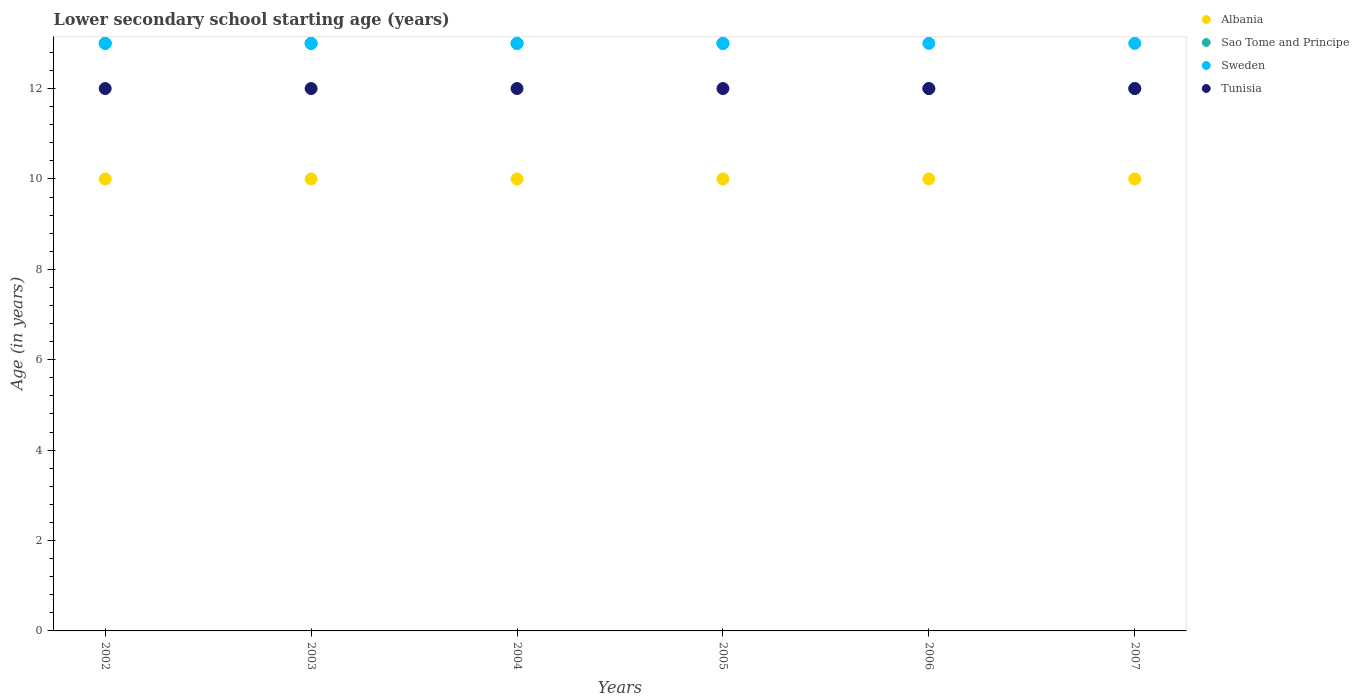What is the lower secondary school starting age of children in Tunisia in 2006?
Offer a very short reply. 12. Across all years, what is the maximum lower secondary school starting age of children in Sao Tome and Principe?
Give a very brief answer. 13. Across all years, what is the minimum lower secondary school starting age of children in Albania?
Offer a terse response. 10. In which year was the lower secondary school starting age of children in Albania minimum?
Ensure brevity in your answer.  2002. What is the total lower secondary school starting age of children in Albania in the graph?
Provide a succinct answer. 60. What is the difference between the lower secondary school starting age of children in Tunisia in 2003 and the lower secondary school starting age of children in Albania in 2007?
Offer a very short reply. 2. Is the difference between the lower secondary school starting age of children in Albania in 2003 and 2005 greater than the difference between the lower secondary school starting age of children in Sweden in 2003 and 2005?
Offer a very short reply. No. In how many years, is the lower secondary school starting age of children in Tunisia greater than the average lower secondary school starting age of children in Tunisia taken over all years?
Offer a very short reply. 0. Is it the case that in every year, the sum of the lower secondary school starting age of children in Albania and lower secondary school starting age of children in Tunisia  is greater than the lower secondary school starting age of children in Sao Tome and Principe?
Offer a very short reply. Yes. Does the lower secondary school starting age of children in Sao Tome and Principe monotonically increase over the years?
Offer a terse response. No. How many years are there in the graph?
Your answer should be compact. 6. What is the difference between two consecutive major ticks on the Y-axis?
Give a very brief answer. 2. Are the values on the major ticks of Y-axis written in scientific E-notation?
Your answer should be compact. No. Does the graph contain any zero values?
Keep it short and to the point. No. Does the graph contain grids?
Your answer should be very brief. No. How many legend labels are there?
Provide a short and direct response. 4. How are the legend labels stacked?
Give a very brief answer. Vertical. What is the title of the graph?
Your answer should be compact. Lower secondary school starting age (years). What is the label or title of the X-axis?
Keep it short and to the point. Years. What is the label or title of the Y-axis?
Your answer should be very brief. Age (in years). What is the Age (in years) of Albania in 2002?
Provide a succinct answer. 10. What is the Age (in years) in Albania in 2003?
Provide a short and direct response. 10. What is the Age (in years) of Sao Tome and Principe in 2003?
Your response must be concise. 13. What is the Age (in years) of Sao Tome and Principe in 2004?
Provide a short and direct response. 13. What is the Age (in years) in Tunisia in 2004?
Offer a terse response. 12. What is the Age (in years) of Albania in 2005?
Offer a terse response. 10. What is the Age (in years) of Tunisia in 2005?
Provide a short and direct response. 12. What is the Age (in years) in Albania in 2006?
Keep it short and to the point. 10. What is the Age (in years) of Sao Tome and Principe in 2006?
Your response must be concise. 12. What is the Age (in years) in Sweden in 2006?
Provide a short and direct response. 13. What is the Age (in years) of Sweden in 2007?
Make the answer very short. 13. What is the Age (in years) in Tunisia in 2007?
Offer a terse response. 12. Across all years, what is the maximum Age (in years) in Sao Tome and Principe?
Your answer should be very brief. 13. Across all years, what is the maximum Age (in years) of Sweden?
Provide a short and direct response. 13. Across all years, what is the maximum Age (in years) in Tunisia?
Keep it short and to the point. 12. Across all years, what is the minimum Age (in years) in Sao Tome and Principe?
Give a very brief answer. 12. Across all years, what is the minimum Age (in years) of Tunisia?
Ensure brevity in your answer.  12. What is the total Age (in years) in Albania in the graph?
Give a very brief answer. 60. What is the total Age (in years) of Sao Tome and Principe in the graph?
Your answer should be compact. 76. What is the total Age (in years) of Tunisia in the graph?
Give a very brief answer. 72. What is the difference between the Age (in years) of Albania in 2002 and that in 2003?
Provide a succinct answer. 0. What is the difference between the Age (in years) in Sao Tome and Principe in 2002 and that in 2003?
Provide a succinct answer. 0. What is the difference between the Age (in years) of Sweden in 2002 and that in 2003?
Offer a very short reply. 0. What is the difference between the Age (in years) in Tunisia in 2002 and that in 2003?
Give a very brief answer. 0. What is the difference between the Age (in years) of Albania in 2002 and that in 2004?
Keep it short and to the point. 0. What is the difference between the Age (in years) in Sao Tome and Principe in 2002 and that in 2004?
Provide a short and direct response. 0. What is the difference between the Age (in years) of Sweden in 2002 and that in 2004?
Make the answer very short. 0. What is the difference between the Age (in years) in Sao Tome and Principe in 2002 and that in 2005?
Keep it short and to the point. 0. What is the difference between the Age (in years) of Sweden in 2002 and that in 2005?
Keep it short and to the point. 0. What is the difference between the Age (in years) in Sao Tome and Principe in 2002 and that in 2006?
Make the answer very short. 1. What is the difference between the Age (in years) in Sweden in 2002 and that in 2006?
Ensure brevity in your answer.  0. What is the difference between the Age (in years) of Tunisia in 2002 and that in 2006?
Ensure brevity in your answer.  0. What is the difference between the Age (in years) of Albania in 2002 and that in 2007?
Offer a terse response. 0. What is the difference between the Age (in years) in Sao Tome and Principe in 2002 and that in 2007?
Your response must be concise. 1. What is the difference between the Age (in years) in Sweden in 2003 and that in 2004?
Keep it short and to the point. 0. What is the difference between the Age (in years) in Albania in 2003 and that in 2005?
Give a very brief answer. 0. What is the difference between the Age (in years) of Sao Tome and Principe in 2003 and that in 2005?
Make the answer very short. 0. What is the difference between the Age (in years) in Albania in 2003 and that in 2006?
Offer a terse response. 0. What is the difference between the Age (in years) of Sao Tome and Principe in 2003 and that in 2006?
Offer a very short reply. 1. What is the difference between the Age (in years) of Albania in 2003 and that in 2007?
Keep it short and to the point. 0. What is the difference between the Age (in years) of Sweden in 2003 and that in 2007?
Your response must be concise. 0. What is the difference between the Age (in years) in Tunisia in 2003 and that in 2007?
Keep it short and to the point. 0. What is the difference between the Age (in years) in Albania in 2004 and that in 2005?
Provide a succinct answer. 0. What is the difference between the Age (in years) of Albania in 2005 and that in 2006?
Your answer should be very brief. 0. What is the difference between the Age (in years) of Sweden in 2005 and that in 2006?
Give a very brief answer. 0. What is the difference between the Age (in years) in Tunisia in 2005 and that in 2006?
Offer a terse response. 0. What is the difference between the Age (in years) in Sao Tome and Principe in 2005 and that in 2007?
Give a very brief answer. 1. What is the difference between the Age (in years) of Sweden in 2005 and that in 2007?
Offer a terse response. 0. What is the difference between the Age (in years) in Sao Tome and Principe in 2006 and that in 2007?
Ensure brevity in your answer.  0. What is the difference between the Age (in years) in Sweden in 2006 and that in 2007?
Offer a very short reply. 0. What is the difference between the Age (in years) in Albania in 2002 and the Age (in years) in Sao Tome and Principe in 2003?
Ensure brevity in your answer.  -3. What is the difference between the Age (in years) of Albania in 2002 and the Age (in years) of Sweden in 2003?
Offer a very short reply. -3. What is the difference between the Age (in years) of Sao Tome and Principe in 2002 and the Age (in years) of Tunisia in 2003?
Your answer should be very brief. 1. What is the difference between the Age (in years) of Sweden in 2002 and the Age (in years) of Tunisia in 2003?
Give a very brief answer. 1. What is the difference between the Age (in years) of Albania in 2002 and the Age (in years) of Sweden in 2004?
Your response must be concise. -3. What is the difference between the Age (in years) in Sao Tome and Principe in 2002 and the Age (in years) in Sweden in 2004?
Offer a very short reply. 0. What is the difference between the Age (in years) in Albania in 2002 and the Age (in years) in Sao Tome and Principe in 2005?
Your answer should be very brief. -3. What is the difference between the Age (in years) in Albania in 2002 and the Age (in years) in Sweden in 2005?
Provide a succinct answer. -3. What is the difference between the Age (in years) in Albania in 2002 and the Age (in years) in Tunisia in 2005?
Ensure brevity in your answer.  -2. What is the difference between the Age (in years) in Sao Tome and Principe in 2002 and the Age (in years) in Sweden in 2005?
Your answer should be compact. 0. What is the difference between the Age (in years) of Sao Tome and Principe in 2002 and the Age (in years) of Tunisia in 2005?
Give a very brief answer. 1. What is the difference between the Age (in years) in Sweden in 2002 and the Age (in years) in Tunisia in 2005?
Provide a short and direct response. 1. What is the difference between the Age (in years) in Albania in 2002 and the Age (in years) in Sweden in 2006?
Your answer should be very brief. -3. What is the difference between the Age (in years) of Sao Tome and Principe in 2002 and the Age (in years) of Sweden in 2006?
Provide a succinct answer. 0. What is the difference between the Age (in years) in Sao Tome and Principe in 2002 and the Age (in years) in Tunisia in 2006?
Keep it short and to the point. 1. What is the difference between the Age (in years) in Sweden in 2002 and the Age (in years) in Tunisia in 2006?
Ensure brevity in your answer.  1. What is the difference between the Age (in years) in Albania in 2002 and the Age (in years) in Tunisia in 2007?
Provide a succinct answer. -2. What is the difference between the Age (in years) in Sao Tome and Principe in 2002 and the Age (in years) in Sweden in 2007?
Offer a very short reply. 0. What is the difference between the Age (in years) in Albania in 2003 and the Age (in years) in Sweden in 2004?
Give a very brief answer. -3. What is the difference between the Age (in years) in Sweden in 2003 and the Age (in years) in Tunisia in 2004?
Give a very brief answer. 1. What is the difference between the Age (in years) of Albania in 2003 and the Age (in years) of Sao Tome and Principe in 2005?
Provide a short and direct response. -3. What is the difference between the Age (in years) of Albania in 2003 and the Age (in years) of Sweden in 2005?
Your answer should be compact. -3. What is the difference between the Age (in years) of Albania in 2003 and the Age (in years) of Tunisia in 2005?
Your response must be concise. -2. What is the difference between the Age (in years) of Sao Tome and Principe in 2003 and the Age (in years) of Sweden in 2005?
Offer a very short reply. 0. What is the difference between the Age (in years) in Sao Tome and Principe in 2003 and the Age (in years) in Tunisia in 2005?
Your response must be concise. 1. What is the difference between the Age (in years) of Albania in 2003 and the Age (in years) of Sao Tome and Principe in 2006?
Make the answer very short. -2. What is the difference between the Age (in years) in Albania in 2003 and the Age (in years) in Sweden in 2006?
Give a very brief answer. -3. What is the difference between the Age (in years) in Sao Tome and Principe in 2003 and the Age (in years) in Sweden in 2006?
Offer a very short reply. 0. What is the difference between the Age (in years) of Albania in 2003 and the Age (in years) of Sao Tome and Principe in 2007?
Keep it short and to the point. -2. What is the difference between the Age (in years) in Albania in 2003 and the Age (in years) in Sweden in 2007?
Ensure brevity in your answer.  -3. What is the difference between the Age (in years) of Sao Tome and Principe in 2003 and the Age (in years) of Sweden in 2007?
Ensure brevity in your answer.  0. What is the difference between the Age (in years) in Albania in 2004 and the Age (in years) in Sweden in 2005?
Your response must be concise. -3. What is the difference between the Age (in years) of Albania in 2004 and the Age (in years) of Tunisia in 2005?
Provide a short and direct response. -2. What is the difference between the Age (in years) in Sao Tome and Principe in 2004 and the Age (in years) in Sweden in 2005?
Provide a short and direct response. 0. What is the difference between the Age (in years) of Sweden in 2004 and the Age (in years) of Tunisia in 2005?
Offer a terse response. 1. What is the difference between the Age (in years) in Albania in 2004 and the Age (in years) in Sao Tome and Principe in 2006?
Provide a succinct answer. -2. What is the difference between the Age (in years) in Albania in 2004 and the Age (in years) in Sweden in 2006?
Your answer should be very brief. -3. What is the difference between the Age (in years) of Sao Tome and Principe in 2004 and the Age (in years) of Sweden in 2006?
Provide a succinct answer. 0. What is the difference between the Age (in years) in Albania in 2004 and the Age (in years) in Sao Tome and Principe in 2007?
Offer a very short reply. -2. What is the difference between the Age (in years) of Sao Tome and Principe in 2004 and the Age (in years) of Sweden in 2007?
Offer a terse response. 0. What is the difference between the Age (in years) in Sao Tome and Principe in 2004 and the Age (in years) in Tunisia in 2007?
Provide a succinct answer. 1. What is the difference between the Age (in years) in Sweden in 2004 and the Age (in years) in Tunisia in 2007?
Offer a terse response. 1. What is the difference between the Age (in years) in Albania in 2005 and the Age (in years) in Sao Tome and Principe in 2006?
Your answer should be compact. -2. What is the difference between the Age (in years) of Albania in 2005 and the Age (in years) of Sweden in 2006?
Ensure brevity in your answer.  -3. What is the difference between the Age (in years) in Sao Tome and Principe in 2005 and the Age (in years) in Sweden in 2006?
Provide a short and direct response. 0. What is the difference between the Age (in years) in Sao Tome and Principe in 2005 and the Age (in years) in Tunisia in 2006?
Your answer should be compact. 1. What is the difference between the Age (in years) of Albania in 2005 and the Age (in years) of Sweden in 2007?
Give a very brief answer. -3. What is the difference between the Age (in years) in Albania in 2005 and the Age (in years) in Tunisia in 2007?
Ensure brevity in your answer.  -2. What is the difference between the Age (in years) in Sao Tome and Principe in 2005 and the Age (in years) in Tunisia in 2007?
Ensure brevity in your answer.  1. What is the difference between the Age (in years) in Sao Tome and Principe in 2006 and the Age (in years) in Sweden in 2007?
Ensure brevity in your answer.  -1. What is the difference between the Age (in years) in Sao Tome and Principe in 2006 and the Age (in years) in Tunisia in 2007?
Offer a very short reply. 0. What is the difference between the Age (in years) in Sweden in 2006 and the Age (in years) in Tunisia in 2007?
Provide a short and direct response. 1. What is the average Age (in years) of Albania per year?
Ensure brevity in your answer.  10. What is the average Age (in years) of Sao Tome and Principe per year?
Provide a short and direct response. 12.67. What is the average Age (in years) in Tunisia per year?
Ensure brevity in your answer.  12. In the year 2002, what is the difference between the Age (in years) of Albania and Age (in years) of Sweden?
Provide a succinct answer. -3. In the year 2002, what is the difference between the Age (in years) of Albania and Age (in years) of Tunisia?
Provide a succinct answer. -2. In the year 2002, what is the difference between the Age (in years) in Sao Tome and Principe and Age (in years) in Sweden?
Your answer should be compact. 0. In the year 2003, what is the difference between the Age (in years) of Albania and Age (in years) of Sao Tome and Principe?
Keep it short and to the point. -3. In the year 2003, what is the difference between the Age (in years) of Albania and Age (in years) of Sweden?
Give a very brief answer. -3. In the year 2003, what is the difference between the Age (in years) of Albania and Age (in years) of Tunisia?
Keep it short and to the point. -2. In the year 2003, what is the difference between the Age (in years) of Sao Tome and Principe and Age (in years) of Tunisia?
Offer a terse response. 1. In the year 2004, what is the difference between the Age (in years) in Albania and Age (in years) in Tunisia?
Your response must be concise. -2. In the year 2005, what is the difference between the Age (in years) of Albania and Age (in years) of Sao Tome and Principe?
Offer a very short reply. -3. In the year 2005, what is the difference between the Age (in years) in Albania and Age (in years) in Sweden?
Provide a short and direct response. -3. In the year 2005, what is the difference between the Age (in years) in Albania and Age (in years) in Tunisia?
Make the answer very short. -2. In the year 2006, what is the difference between the Age (in years) of Albania and Age (in years) of Sao Tome and Principe?
Your response must be concise. -2. In the year 2006, what is the difference between the Age (in years) in Albania and Age (in years) in Tunisia?
Your answer should be compact. -2. In the year 2006, what is the difference between the Age (in years) of Sao Tome and Principe and Age (in years) of Sweden?
Your answer should be very brief. -1. In the year 2006, what is the difference between the Age (in years) of Sweden and Age (in years) of Tunisia?
Make the answer very short. 1. In the year 2007, what is the difference between the Age (in years) of Albania and Age (in years) of Sao Tome and Principe?
Ensure brevity in your answer.  -2. In the year 2007, what is the difference between the Age (in years) of Albania and Age (in years) of Sweden?
Keep it short and to the point. -3. In the year 2007, what is the difference between the Age (in years) of Sao Tome and Principe and Age (in years) of Tunisia?
Your answer should be compact. 0. In the year 2007, what is the difference between the Age (in years) in Sweden and Age (in years) in Tunisia?
Your response must be concise. 1. What is the ratio of the Age (in years) in Sao Tome and Principe in 2002 to that in 2003?
Give a very brief answer. 1. What is the ratio of the Age (in years) in Sao Tome and Principe in 2002 to that in 2005?
Your answer should be compact. 1. What is the ratio of the Age (in years) in Sweden in 2002 to that in 2005?
Your answer should be compact. 1. What is the ratio of the Age (in years) in Sao Tome and Principe in 2002 to that in 2006?
Make the answer very short. 1.08. What is the ratio of the Age (in years) in Sweden in 2002 to that in 2007?
Give a very brief answer. 1. What is the ratio of the Age (in years) in Tunisia in 2002 to that in 2007?
Provide a succinct answer. 1. What is the ratio of the Age (in years) in Albania in 2003 to that in 2004?
Provide a succinct answer. 1. What is the ratio of the Age (in years) in Sweden in 2003 to that in 2004?
Give a very brief answer. 1. What is the ratio of the Age (in years) of Albania in 2003 to that in 2005?
Make the answer very short. 1. What is the ratio of the Age (in years) in Sao Tome and Principe in 2003 to that in 2005?
Offer a terse response. 1. What is the ratio of the Age (in years) of Sweden in 2003 to that in 2005?
Give a very brief answer. 1. What is the ratio of the Age (in years) of Albania in 2003 to that in 2006?
Make the answer very short. 1. What is the ratio of the Age (in years) of Tunisia in 2003 to that in 2006?
Provide a short and direct response. 1. What is the ratio of the Age (in years) of Sao Tome and Principe in 2003 to that in 2007?
Make the answer very short. 1.08. What is the ratio of the Age (in years) in Tunisia in 2003 to that in 2007?
Keep it short and to the point. 1. What is the ratio of the Age (in years) in Tunisia in 2004 to that in 2005?
Provide a succinct answer. 1. What is the ratio of the Age (in years) of Sao Tome and Principe in 2004 to that in 2006?
Your answer should be very brief. 1.08. What is the ratio of the Age (in years) of Albania in 2004 to that in 2007?
Offer a very short reply. 1. What is the ratio of the Age (in years) in Sao Tome and Principe in 2004 to that in 2007?
Provide a short and direct response. 1.08. What is the ratio of the Age (in years) of Sweden in 2004 to that in 2007?
Give a very brief answer. 1. What is the ratio of the Age (in years) in Tunisia in 2004 to that in 2007?
Keep it short and to the point. 1. What is the ratio of the Age (in years) in Albania in 2005 to that in 2006?
Keep it short and to the point. 1. What is the ratio of the Age (in years) in Sweden in 2005 to that in 2006?
Keep it short and to the point. 1. What is the ratio of the Age (in years) of Tunisia in 2005 to that in 2007?
Ensure brevity in your answer.  1. What is the ratio of the Age (in years) in Sao Tome and Principe in 2006 to that in 2007?
Your answer should be very brief. 1. What is the ratio of the Age (in years) in Tunisia in 2006 to that in 2007?
Provide a short and direct response. 1. What is the difference between the highest and the second highest Age (in years) of Albania?
Offer a terse response. 0. What is the difference between the highest and the second highest Age (in years) in Sweden?
Keep it short and to the point. 0. What is the difference between the highest and the lowest Age (in years) of Sao Tome and Principe?
Offer a terse response. 1. 